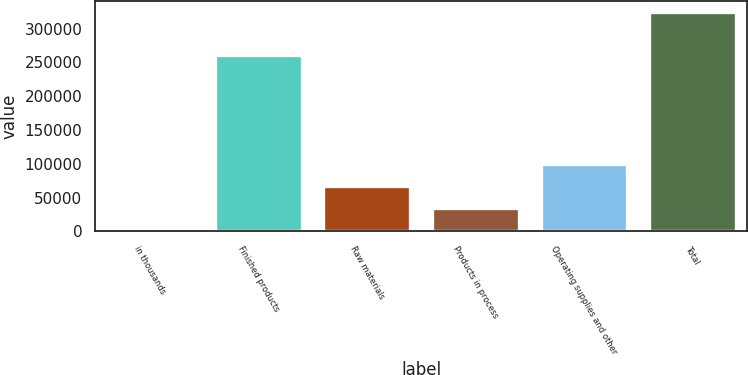Convert chart. <chart><loc_0><loc_0><loc_500><loc_500><bar_chart><fcel>in thousands<fcel>Finished products<fcel>Raw materials<fcel>Products in process<fcel>Operating supplies and other<fcel>Total<nl><fcel>2009<fcel>261752<fcel>66613.8<fcel>34311.4<fcel>98916.2<fcel>325033<nl></chart> 